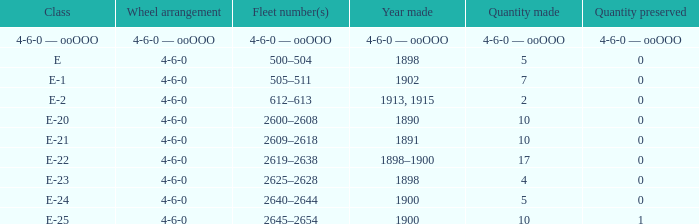Parse the table in full. {'header': ['Class', 'Wheel arrangement', 'Fleet number(s)', 'Year made', 'Quantity made', 'Quantity preserved'], 'rows': [['4-6-0 — ooOOO', '4-6-0 — ooOOO', '4-6-0 — ooOOO', '4-6-0 — ooOOO', '4-6-0 — ooOOO', '4-6-0 — ooOOO'], ['E', '4-6-0', '500–504', '1898', '5', '0'], ['E-1', '4-6-0', '505–511', '1902', '7', '0'], ['E-2', '4-6-0', '612–613', '1913, 1915', '2', '0'], ['E-20', '4-6-0', '2600–2608', '1890', '10', '0'], ['E-21', '4-6-0', '2609–2618', '1891', '10', '0'], ['E-22', '4-6-0', '2619–2638', '1898–1900', '17', '0'], ['E-23', '4-6-0', '2625–2628', '1898', '4', '0'], ['E-24', '4-6-0', '2640–2644', '1900', '5', '0'], ['E-25', '4-6-0', '2645–2654', '1900', '10', '1']]} What is the volume created of the e-22 class, which has a conserved volume of 0? 17.0. 